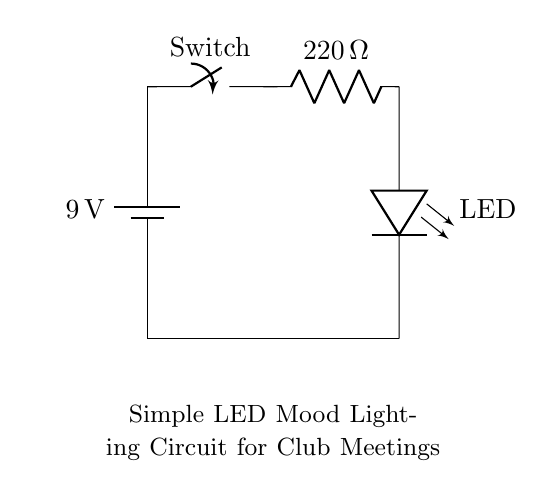What is the voltage of this circuit? The circuit has a voltage supply of 9 volts, as indicated next to the battery component at the top of the circuit diagram.
Answer: 9 volts What type of component is used for mood lighting? The circuit includes an LED component, marked as "LED," which is specifically used for emitting light and creates ambiance.
Answer: LED What is the resistance value in the circuit? A resistor is included in the circuit, shown with a label of "220 ohms," which indicates its resistance value, as noted next to the resistor component.
Answer: 220 ohms How many components are in this circuit? There are four distinct components in this circuit: a battery, a switch, a resistor, and an LED. By counting these components directly from the diagram, we arrive at the total.
Answer: Four What is the function of the switch in the circuit? The switch is shown in the circuit labeled "Switch," and its purpose is to open or close the circuit, allowing control over the flow of electricity to the LED. When closed, it allows current to flow; when open, it interrupts the flow.
Answer: To control the circuit What is the flow direction of current in this circuit? The current flows from the positive terminal of the battery, through the switch, then through the resistor, and finally to the LED, after which it returns to the negative terminal of the battery, following the path depicted in the diagram.
Answer: From top to bottom What would happen if the resistor value is too low? If the resistor value were too low, it could cause too much current to flow through the LED, potentially damaging it or causing it to fail. The resistor is essential for limiting the current to appropriate levels for the LED's safe operation.
Answer: Risk of damage 